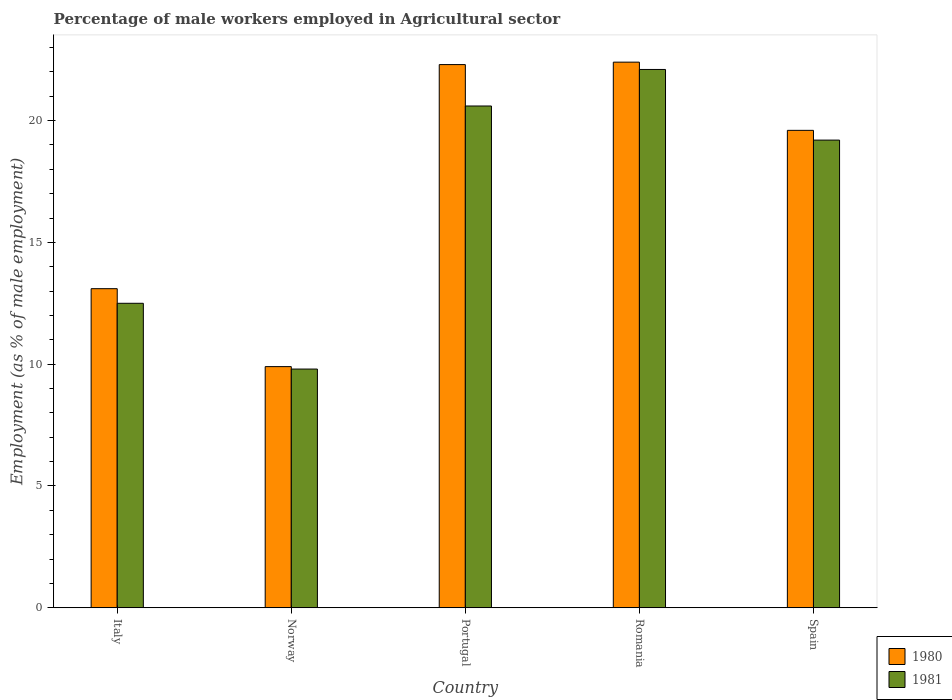How many different coloured bars are there?
Offer a terse response. 2. How many bars are there on the 4th tick from the right?
Ensure brevity in your answer.  2. In how many cases, is the number of bars for a given country not equal to the number of legend labels?
Your answer should be very brief. 0. What is the percentage of male workers employed in Agricultural sector in 1980 in Spain?
Offer a terse response. 19.6. Across all countries, what is the maximum percentage of male workers employed in Agricultural sector in 1980?
Give a very brief answer. 22.4. Across all countries, what is the minimum percentage of male workers employed in Agricultural sector in 1980?
Your answer should be very brief. 9.9. In which country was the percentage of male workers employed in Agricultural sector in 1981 maximum?
Offer a very short reply. Romania. What is the total percentage of male workers employed in Agricultural sector in 1981 in the graph?
Make the answer very short. 84.2. What is the difference between the percentage of male workers employed in Agricultural sector in 1980 in Portugal and that in Romania?
Provide a succinct answer. -0.1. What is the difference between the percentage of male workers employed in Agricultural sector in 1980 in Romania and the percentage of male workers employed in Agricultural sector in 1981 in Spain?
Provide a short and direct response. 3.2. What is the average percentage of male workers employed in Agricultural sector in 1980 per country?
Offer a very short reply. 17.46. What is the difference between the percentage of male workers employed in Agricultural sector of/in 1981 and percentage of male workers employed in Agricultural sector of/in 1980 in Portugal?
Provide a succinct answer. -1.7. What is the ratio of the percentage of male workers employed in Agricultural sector in 1981 in Italy to that in Norway?
Your answer should be very brief. 1.28. Is the percentage of male workers employed in Agricultural sector in 1981 in Italy less than that in Spain?
Your answer should be very brief. Yes. Is the difference between the percentage of male workers employed in Agricultural sector in 1981 in Portugal and Spain greater than the difference between the percentage of male workers employed in Agricultural sector in 1980 in Portugal and Spain?
Provide a succinct answer. No. What is the difference between the highest and the second highest percentage of male workers employed in Agricultural sector in 1981?
Ensure brevity in your answer.  -1.4. What is the difference between the highest and the lowest percentage of male workers employed in Agricultural sector in 1981?
Your answer should be compact. 12.3. Is the sum of the percentage of male workers employed in Agricultural sector in 1981 in Italy and Portugal greater than the maximum percentage of male workers employed in Agricultural sector in 1980 across all countries?
Your answer should be very brief. Yes. What does the 2nd bar from the left in Portugal represents?
Offer a very short reply. 1981. How many bars are there?
Keep it short and to the point. 10. Are all the bars in the graph horizontal?
Offer a very short reply. No. What is the difference between two consecutive major ticks on the Y-axis?
Ensure brevity in your answer.  5. Where does the legend appear in the graph?
Your response must be concise. Bottom right. How many legend labels are there?
Give a very brief answer. 2. What is the title of the graph?
Provide a succinct answer. Percentage of male workers employed in Agricultural sector. What is the label or title of the X-axis?
Give a very brief answer. Country. What is the label or title of the Y-axis?
Provide a succinct answer. Employment (as % of male employment). What is the Employment (as % of male employment) of 1980 in Italy?
Offer a very short reply. 13.1. What is the Employment (as % of male employment) in 1980 in Norway?
Offer a very short reply. 9.9. What is the Employment (as % of male employment) of 1981 in Norway?
Offer a terse response. 9.8. What is the Employment (as % of male employment) in 1980 in Portugal?
Give a very brief answer. 22.3. What is the Employment (as % of male employment) in 1981 in Portugal?
Give a very brief answer. 20.6. What is the Employment (as % of male employment) in 1980 in Romania?
Make the answer very short. 22.4. What is the Employment (as % of male employment) of 1981 in Romania?
Make the answer very short. 22.1. What is the Employment (as % of male employment) in 1980 in Spain?
Give a very brief answer. 19.6. What is the Employment (as % of male employment) of 1981 in Spain?
Your response must be concise. 19.2. Across all countries, what is the maximum Employment (as % of male employment) in 1980?
Keep it short and to the point. 22.4. Across all countries, what is the maximum Employment (as % of male employment) of 1981?
Provide a short and direct response. 22.1. Across all countries, what is the minimum Employment (as % of male employment) in 1980?
Offer a very short reply. 9.9. Across all countries, what is the minimum Employment (as % of male employment) in 1981?
Provide a short and direct response. 9.8. What is the total Employment (as % of male employment) in 1980 in the graph?
Your answer should be very brief. 87.3. What is the total Employment (as % of male employment) in 1981 in the graph?
Your answer should be very brief. 84.2. What is the difference between the Employment (as % of male employment) in 1981 in Italy and that in Norway?
Make the answer very short. 2.7. What is the difference between the Employment (as % of male employment) in 1980 in Italy and that in Portugal?
Provide a short and direct response. -9.2. What is the difference between the Employment (as % of male employment) of 1981 in Italy and that in Portugal?
Ensure brevity in your answer.  -8.1. What is the difference between the Employment (as % of male employment) of 1980 in Italy and that in Romania?
Ensure brevity in your answer.  -9.3. What is the difference between the Employment (as % of male employment) in 1980 in Italy and that in Spain?
Give a very brief answer. -6.5. What is the difference between the Employment (as % of male employment) in 1981 in Italy and that in Spain?
Your response must be concise. -6.7. What is the difference between the Employment (as % of male employment) in 1980 in Norway and that in Portugal?
Give a very brief answer. -12.4. What is the difference between the Employment (as % of male employment) in 1981 in Norway and that in Portugal?
Provide a succinct answer. -10.8. What is the difference between the Employment (as % of male employment) of 1981 in Norway and that in Romania?
Your answer should be compact. -12.3. What is the difference between the Employment (as % of male employment) of 1980 in Portugal and that in Spain?
Make the answer very short. 2.7. What is the difference between the Employment (as % of male employment) in 1981 in Romania and that in Spain?
Ensure brevity in your answer.  2.9. What is the difference between the Employment (as % of male employment) of 1980 in Italy and the Employment (as % of male employment) of 1981 in Norway?
Offer a very short reply. 3.3. What is the difference between the Employment (as % of male employment) of 1980 in Italy and the Employment (as % of male employment) of 1981 in Portugal?
Your answer should be compact. -7.5. What is the difference between the Employment (as % of male employment) in 1980 in Italy and the Employment (as % of male employment) in 1981 in Romania?
Offer a terse response. -9. What is the difference between the Employment (as % of male employment) of 1980 in Italy and the Employment (as % of male employment) of 1981 in Spain?
Keep it short and to the point. -6.1. What is the difference between the Employment (as % of male employment) in 1980 in Norway and the Employment (as % of male employment) in 1981 in Romania?
Offer a very short reply. -12.2. What is the difference between the Employment (as % of male employment) of 1980 in Portugal and the Employment (as % of male employment) of 1981 in Romania?
Ensure brevity in your answer.  0.2. What is the average Employment (as % of male employment) in 1980 per country?
Offer a very short reply. 17.46. What is the average Employment (as % of male employment) of 1981 per country?
Offer a very short reply. 16.84. What is the difference between the Employment (as % of male employment) in 1980 and Employment (as % of male employment) in 1981 in Norway?
Offer a very short reply. 0.1. What is the difference between the Employment (as % of male employment) of 1980 and Employment (as % of male employment) of 1981 in Portugal?
Ensure brevity in your answer.  1.7. What is the ratio of the Employment (as % of male employment) in 1980 in Italy to that in Norway?
Offer a very short reply. 1.32. What is the ratio of the Employment (as % of male employment) of 1981 in Italy to that in Norway?
Provide a short and direct response. 1.28. What is the ratio of the Employment (as % of male employment) of 1980 in Italy to that in Portugal?
Offer a very short reply. 0.59. What is the ratio of the Employment (as % of male employment) of 1981 in Italy to that in Portugal?
Offer a terse response. 0.61. What is the ratio of the Employment (as % of male employment) of 1980 in Italy to that in Romania?
Ensure brevity in your answer.  0.58. What is the ratio of the Employment (as % of male employment) of 1981 in Italy to that in Romania?
Your answer should be very brief. 0.57. What is the ratio of the Employment (as % of male employment) of 1980 in Italy to that in Spain?
Offer a very short reply. 0.67. What is the ratio of the Employment (as % of male employment) in 1981 in Italy to that in Spain?
Keep it short and to the point. 0.65. What is the ratio of the Employment (as % of male employment) in 1980 in Norway to that in Portugal?
Make the answer very short. 0.44. What is the ratio of the Employment (as % of male employment) in 1981 in Norway to that in Portugal?
Give a very brief answer. 0.48. What is the ratio of the Employment (as % of male employment) in 1980 in Norway to that in Romania?
Ensure brevity in your answer.  0.44. What is the ratio of the Employment (as % of male employment) of 1981 in Norway to that in Romania?
Your response must be concise. 0.44. What is the ratio of the Employment (as % of male employment) in 1980 in Norway to that in Spain?
Offer a very short reply. 0.51. What is the ratio of the Employment (as % of male employment) in 1981 in Norway to that in Spain?
Provide a short and direct response. 0.51. What is the ratio of the Employment (as % of male employment) of 1980 in Portugal to that in Romania?
Give a very brief answer. 1. What is the ratio of the Employment (as % of male employment) of 1981 in Portugal to that in Romania?
Provide a short and direct response. 0.93. What is the ratio of the Employment (as % of male employment) in 1980 in Portugal to that in Spain?
Offer a very short reply. 1.14. What is the ratio of the Employment (as % of male employment) of 1981 in Portugal to that in Spain?
Provide a short and direct response. 1.07. What is the ratio of the Employment (as % of male employment) of 1981 in Romania to that in Spain?
Offer a very short reply. 1.15. What is the difference between the highest and the second highest Employment (as % of male employment) in 1980?
Your response must be concise. 0.1. What is the difference between the highest and the second highest Employment (as % of male employment) of 1981?
Your answer should be very brief. 1.5. 